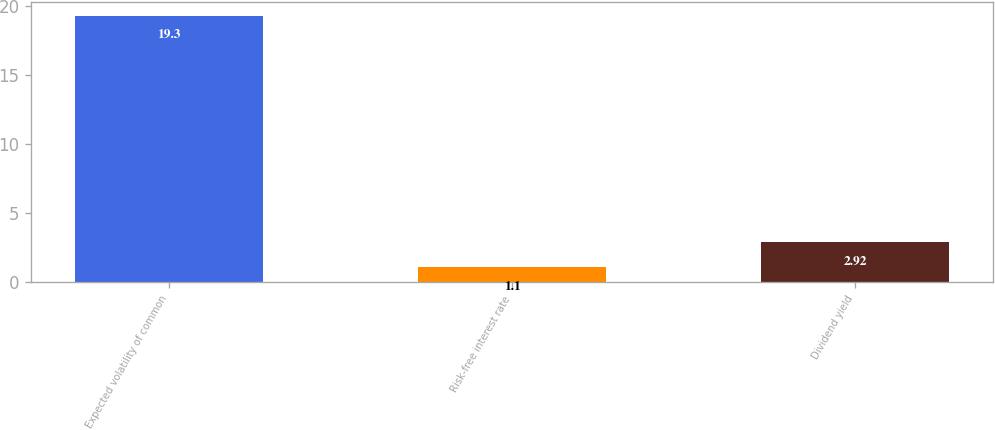<chart> <loc_0><loc_0><loc_500><loc_500><bar_chart><fcel>Expected volatility of common<fcel>Risk-free interest rate<fcel>Dividend yield<nl><fcel>19.3<fcel>1.1<fcel>2.92<nl></chart> 